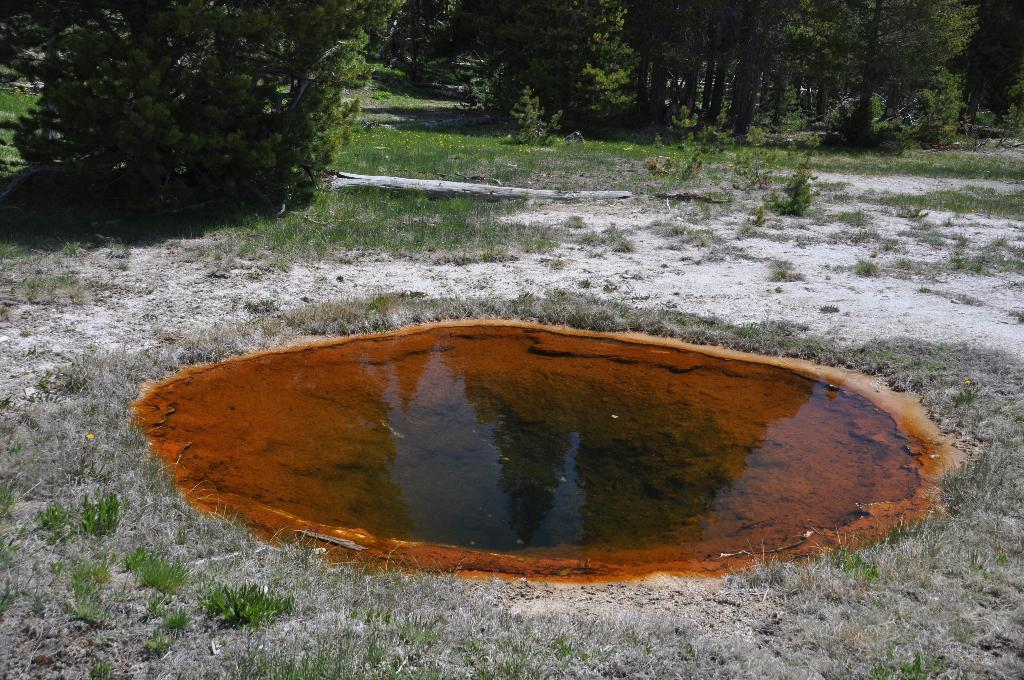What is the main element in the image? There is water in the image. Where is the water located? The water is in a grassy land. What other natural elements can be seen in the image? There are trees visible in the image. How are the trees positioned in the image? The trees are at the top of the image. What type of receipt can be seen floating in the water in the image? There is no receipt present in the image; it only features water, grassy land, and trees. 